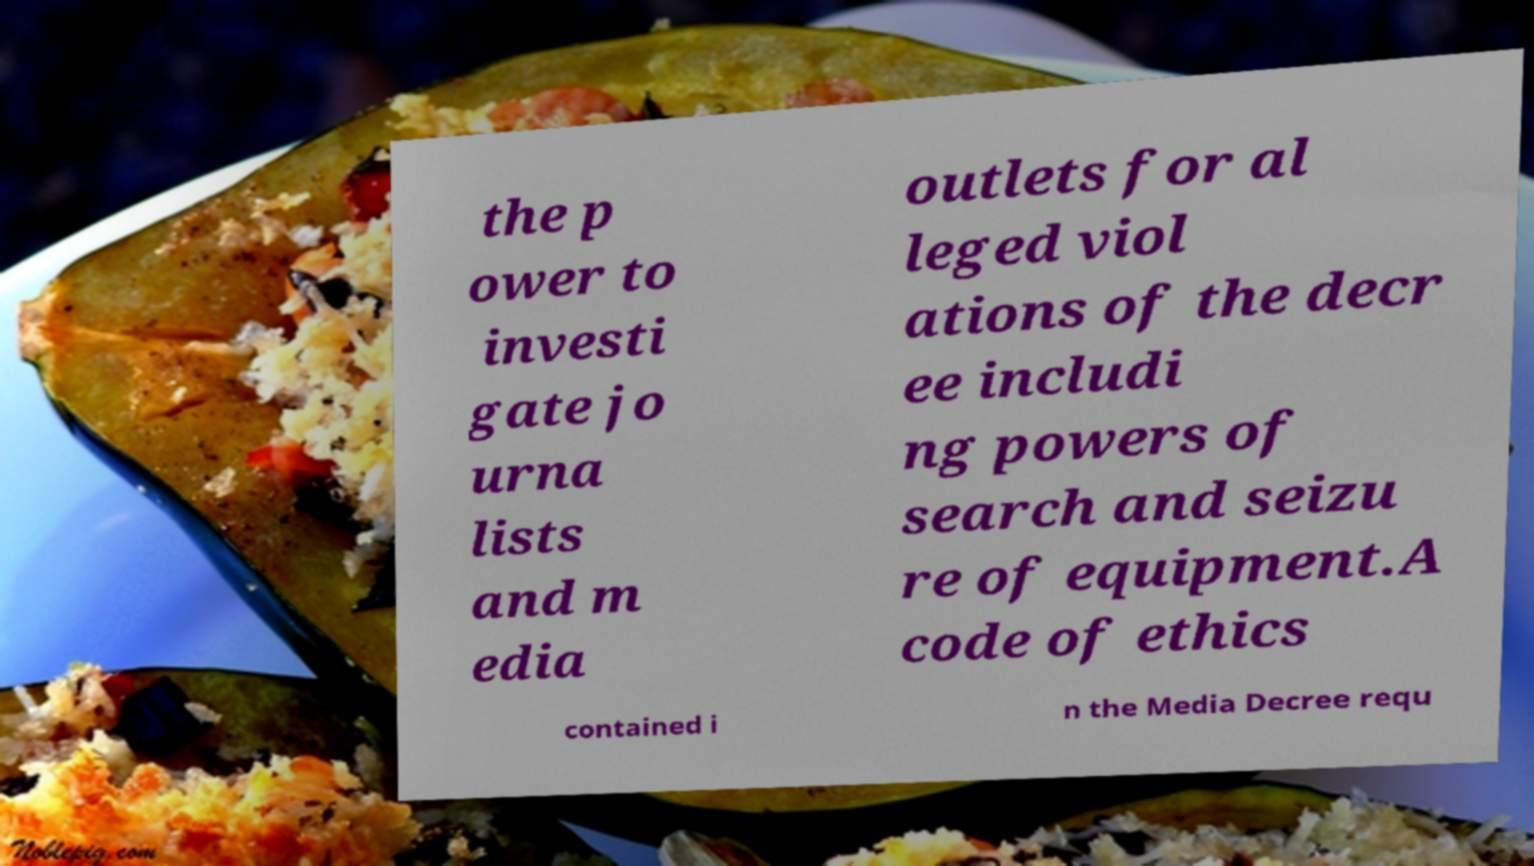Can you accurately transcribe the text from the provided image for me? the p ower to investi gate jo urna lists and m edia outlets for al leged viol ations of the decr ee includi ng powers of search and seizu re of equipment.A code of ethics contained i n the Media Decree requ 